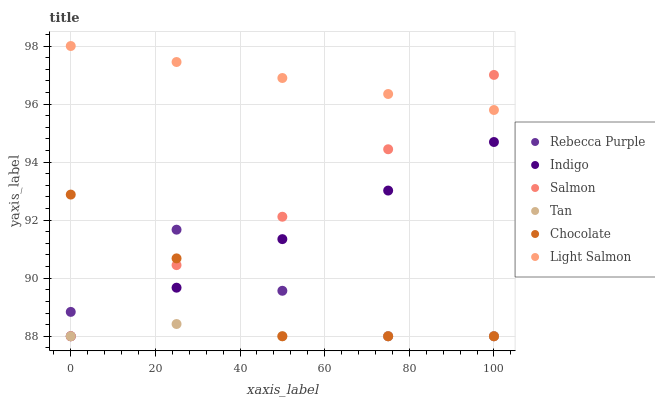Does Tan have the minimum area under the curve?
Answer yes or no. Yes. Does Light Salmon have the maximum area under the curve?
Answer yes or no. Yes. Does Indigo have the minimum area under the curve?
Answer yes or no. No. Does Indigo have the maximum area under the curve?
Answer yes or no. No. Is Light Salmon the smoothest?
Answer yes or no. Yes. Is Rebecca Purple the roughest?
Answer yes or no. Yes. Is Salmon the smoothest?
Answer yes or no. No. Is Salmon the roughest?
Answer yes or no. No. Does Indigo have the lowest value?
Answer yes or no. Yes. Does Light Salmon have the highest value?
Answer yes or no. Yes. Does Indigo have the highest value?
Answer yes or no. No. Is Indigo less than Light Salmon?
Answer yes or no. Yes. Is Light Salmon greater than Tan?
Answer yes or no. Yes. Does Chocolate intersect Rebecca Purple?
Answer yes or no. Yes. Is Chocolate less than Rebecca Purple?
Answer yes or no. No. Is Chocolate greater than Rebecca Purple?
Answer yes or no. No. Does Indigo intersect Light Salmon?
Answer yes or no. No. 